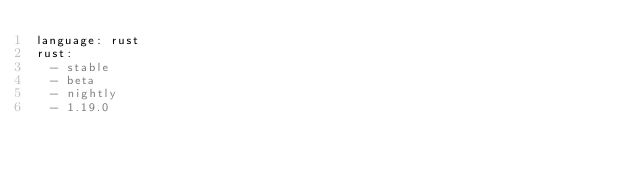Convert code to text. <code><loc_0><loc_0><loc_500><loc_500><_YAML_>language: rust
rust:
  - stable
  - beta
  - nightly
  - 1.19.0
</code> 